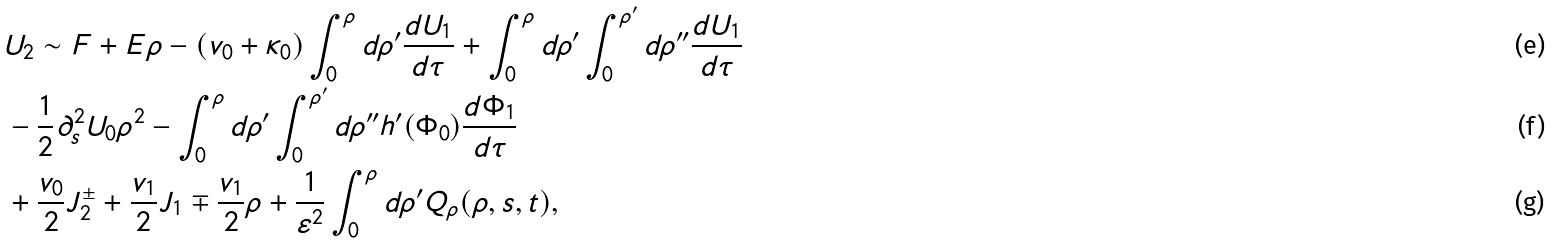<formula> <loc_0><loc_0><loc_500><loc_500>& U _ { 2 } \sim F + E \rho - ( v _ { 0 } + \kappa _ { 0 } ) \int _ { 0 } ^ { \rho } d \rho ^ { \prime } \frac { d U _ { 1 } } { d \tau } + \int _ { 0 } ^ { \rho } d \rho ^ { \prime } \int _ { 0 } ^ { \rho ^ { \prime } } d \rho ^ { \prime \prime } \frac { d U _ { 1 } } { d \tau } \\ & - \frac { 1 } { 2 } \partial ^ { 2 } _ { s } U _ { 0 } \rho ^ { 2 } - \int _ { 0 } ^ { \rho } d \rho ^ { \prime } \int _ { 0 } ^ { \rho ^ { \prime } } d \rho ^ { \prime \prime } h ^ { \prime } ( \Phi _ { 0 } ) \frac { d \Phi _ { 1 } } { d \tau } \\ & + \frac { v _ { 0 } } { 2 } J _ { 2 } ^ { \pm } + \frac { v _ { 1 } } { 2 } J _ { 1 } \mp \frac { v _ { 1 } } { 2 } \rho + \frac { 1 } { \varepsilon ^ { 2 } } \int _ { 0 } ^ { \rho } d \rho ^ { \prime } Q _ { \rho } ( \rho , { s } , t ) ,</formula> 